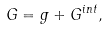<formula> <loc_0><loc_0><loc_500><loc_500>G = g + G ^ { i n t } ,</formula> 